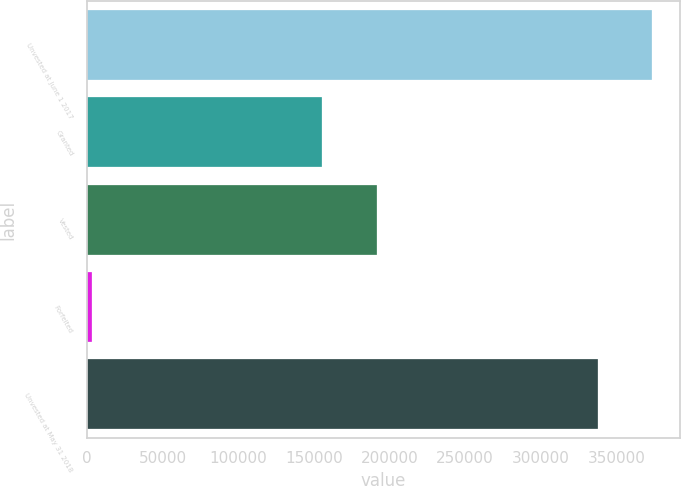Convert chart to OTSL. <chart><loc_0><loc_0><loc_500><loc_500><bar_chart><fcel>Unvested at June 1 2017<fcel>Granted<fcel>Vested<fcel>Forfeited<fcel>Unvested at May 31 2018<nl><fcel>373513<fcel>155624<fcel>191547<fcel>3074<fcel>337590<nl></chart> 